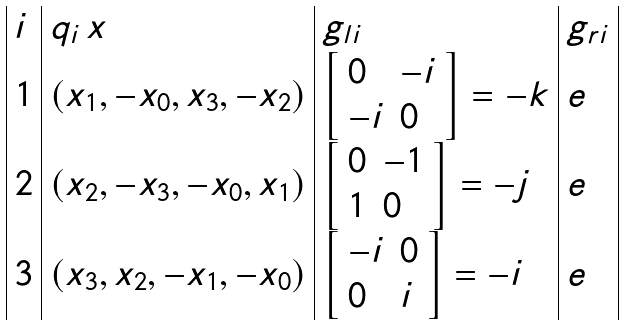<formula> <loc_0><loc_0><loc_500><loc_500>\begin{array} { | l | l | l | l | } i & q _ { i } \, x & g _ { l i } & g _ { r i } \\ 1 & ( x _ { 1 } , - x _ { 0 } , x _ { 3 } , - x _ { 2 } ) & \left [ \begin{array} { l l } 0 & - i \\ - i & 0 \\ \end{array} \right ] = - k & e \\ 2 & ( x _ { 2 } , - x _ { 3 } , - x _ { 0 } , x _ { 1 } ) & \left [ \begin{array} { l l } 0 & - 1 \\ 1 & 0 \\ \end{array} \right ] = - j & e \\ 3 & ( x _ { 3 } , x _ { 2 } , - x _ { 1 } , - x _ { 0 } ) & \left [ \begin{array} { l l } - i & 0 \\ 0 & i \\ \end{array} \right ] = - i & e \\ \end{array}</formula> 